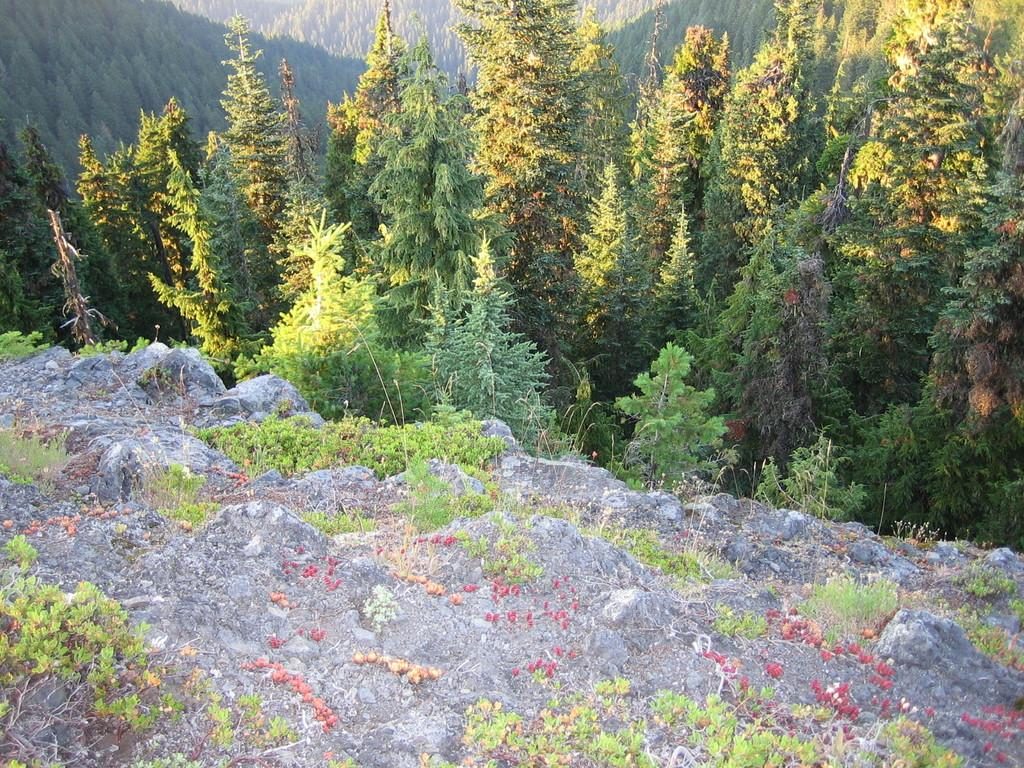What type of vegetation can be seen in the image? There are trees in the image. What other natural elements are present in the image? There is a rock and grass in the image. What color is the ear on the rock in the image? There is no ear present in the image; it only features trees, a rock, and grass. 